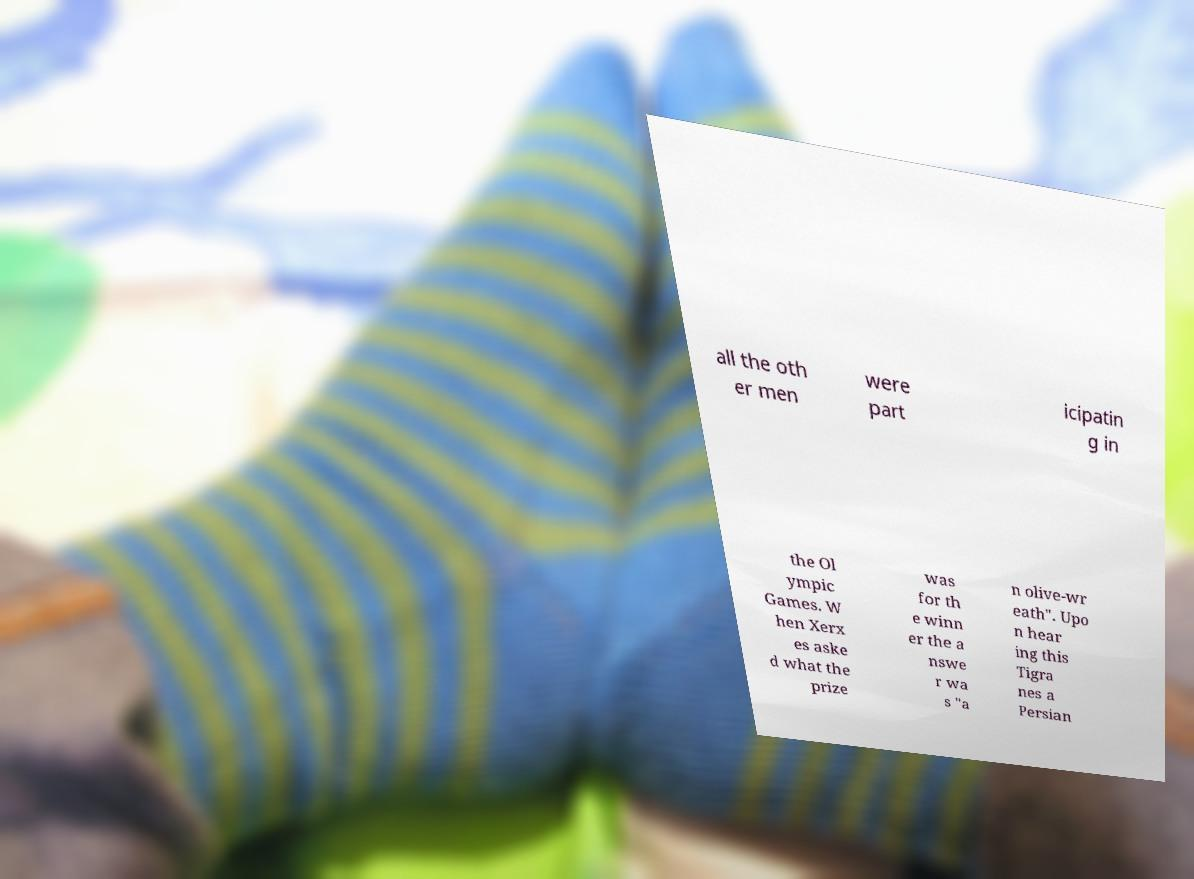Please read and relay the text visible in this image. What does it say? all the oth er men were part icipatin g in the Ol ympic Games. W hen Xerx es aske d what the prize was for th e winn er the a nswe r wa s "a n olive-wr eath". Upo n hear ing this Tigra nes a Persian 